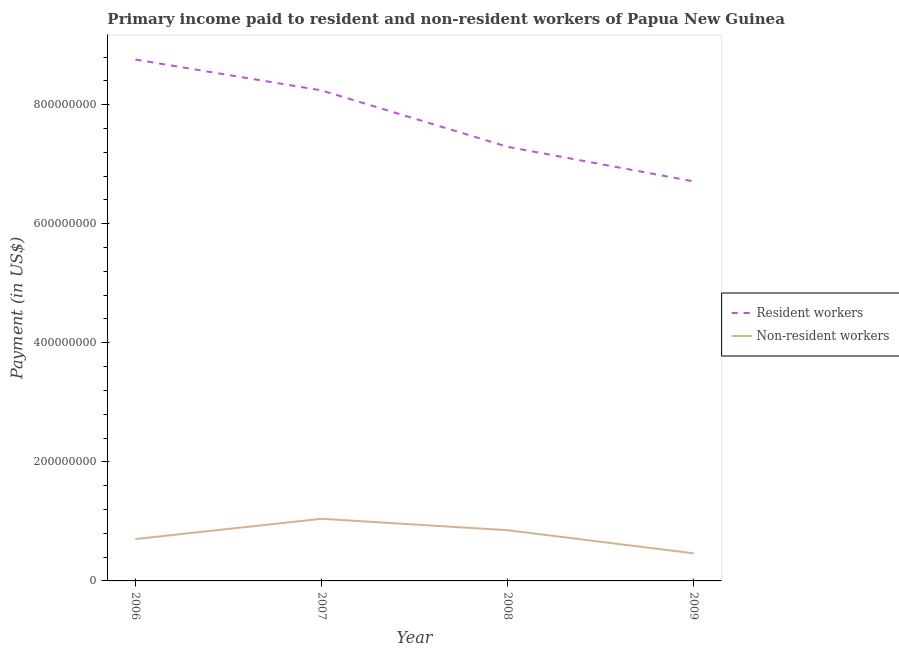Does the line corresponding to payment made to non-resident workers intersect with the line corresponding to payment made to resident workers?
Your response must be concise. No. Is the number of lines equal to the number of legend labels?
Provide a succinct answer. Yes. What is the payment made to non-resident workers in 2006?
Ensure brevity in your answer.  7.03e+07. Across all years, what is the maximum payment made to non-resident workers?
Ensure brevity in your answer.  1.04e+08. Across all years, what is the minimum payment made to non-resident workers?
Offer a terse response. 4.63e+07. In which year was the payment made to resident workers minimum?
Offer a terse response. 2009. What is the total payment made to non-resident workers in the graph?
Keep it short and to the point. 3.06e+08. What is the difference between the payment made to resident workers in 2006 and that in 2009?
Your answer should be compact. 2.05e+08. What is the difference between the payment made to non-resident workers in 2007 and the payment made to resident workers in 2008?
Keep it short and to the point. -6.25e+08. What is the average payment made to resident workers per year?
Ensure brevity in your answer.  7.75e+08. In the year 2009, what is the difference between the payment made to resident workers and payment made to non-resident workers?
Give a very brief answer. 6.25e+08. What is the ratio of the payment made to resident workers in 2008 to that in 2009?
Offer a very short reply. 1.09. Is the payment made to resident workers in 2006 less than that in 2007?
Give a very brief answer. No. What is the difference between the highest and the second highest payment made to non-resident workers?
Keep it short and to the point. 1.92e+07. What is the difference between the highest and the lowest payment made to non-resident workers?
Your answer should be very brief. 5.80e+07. In how many years, is the payment made to resident workers greater than the average payment made to resident workers taken over all years?
Offer a terse response. 2. Is the sum of the payment made to resident workers in 2007 and 2009 greater than the maximum payment made to non-resident workers across all years?
Your response must be concise. Yes. Is the payment made to non-resident workers strictly greater than the payment made to resident workers over the years?
Make the answer very short. No. Is the payment made to non-resident workers strictly less than the payment made to resident workers over the years?
Your response must be concise. Yes. How many lines are there?
Keep it short and to the point. 2. How many years are there in the graph?
Make the answer very short. 4. What is the difference between two consecutive major ticks on the Y-axis?
Offer a terse response. 2.00e+08. Does the graph contain any zero values?
Ensure brevity in your answer.  No. Does the graph contain grids?
Keep it short and to the point. No. Where does the legend appear in the graph?
Offer a very short reply. Center right. What is the title of the graph?
Offer a terse response. Primary income paid to resident and non-resident workers of Papua New Guinea. What is the label or title of the X-axis?
Your answer should be very brief. Year. What is the label or title of the Y-axis?
Ensure brevity in your answer.  Payment (in US$). What is the Payment (in US$) in Resident workers in 2006?
Ensure brevity in your answer.  8.76e+08. What is the Payment (in US$) in Non-resident workers in 2006?
Make the answer very short. 7.03e+07. What is the Payment (in US$) in Resident workers in 2007?
Your answer should be very brief. 8.24e+08. What is the Payment (in US$) of Non-resident workers in 2007?
Your response must be concise. 1.04e+08. What is the Payment (in US$) in Resident workers in 2008?
Offer a very short reply. 7.29e+08. What is the Payment (in US$) in Non-resident workers in 2008?
Your response must be concise. 8.51e+07. What is the Payment (in US$) in Resident workers in 2009?
Your answer should be compact. 6.71e+08. What is the Payment (in US$) in Non-resident workers in 2009?
Offer a very short reply. 4.63e+07. Across all years, what is the maximum Payment (in US$) in Resident workers?
Ensure brevity in your answer.  8.76e+08. Across all years, what is the maximum Payment (in US$) in Non-resident workers?
Provide a short and direct response. 1.04e+08. Across all years, what is the minimum Payment (in US$) of Resident workers?
Keep it short and to the point. 6.71e+08. Across all years, what is the minimum Payment (in US$) of Non-resident workers?
Your response must be concise. 4.63e+07. What is the total Payment (in US$) in Resident workers in the graph?
Offer a terse response. 3.10e+09. What is the total Payment (in US$) in Non-resident workers in the graph?
Your response must be concise. 3.06e+08. What is the difference between the Payment (in US$) of Resident workers in 2006 and that in 2007?
Your answer should be very brief. 5.18e+07. What is the difference between the Payment (in US$) in Non-resident workers in 2006 and that in 2007?
Your answer should be compact. -3.40e+07. What is the difference between the Payment (in US$) of Resident workers in 2006 and that in 2008?
Your answer should be very brief. 1.47e+08. What is the difference between the Payment (in US$) in Non-resident workers in 2006 and that in 2008?
Make the answer very short. -1.48e+07. What is the difference between the Payment (in US$) in Resident workers in 2006 and that in 2009?
Your answer should be very brief. 2.05e+08. What is the difference between the Payment (in US$) of Non-resident workers in 2006 and that in 2009?
Your answer should be compact. 2.40e+07. What is the difference between the Payment (in US$) in Resident workers in 2007 and that in 2008?
Offer a very short reply. 9.48e+07. What is the difference between the Payment (in US$) of Non-resident workers in 2007 and that in 2008?
Make the answer very short. 1.92e+07. What is the difference between the Payment (in US$) of Resident workers in 2007 and that in 2009?
Offer a very short reply. 1.53e+08. What is the difference between the Payment (in US$) in Non-resident workers in 2007 and that in 2009?
Your answer should be very brief. 5.80e+07. What is the difference between the Payment (in US$) of Resident workers in 2008 and that in 2009?
Offer a very short reply. 5.81e+07. What is the difference between the Payment (in US$) of Non-resident workers in 2008 and that in 2009?
Provide a succinct answer. 3.88e+07. What is the difference between the Payment (in US$) of Resident workers in 2006 and the Payment (in US$) of Non-resident workers in 2007?
Make the answer very short. 7.71e+08. What is the difference between the Payment (in US$) in Resident workers in 2006 and the Payment (in US$) in Non-resident workers in 2008?
Provide a succinct answer. 7.91e+08. What is the difference between the Payment (in US$) of Resident workers in 2006 and the Payment (in US$) of Non-resident workers in 2009?
Ensure brevity in your answer.  8.29e+08. What is the difference between the Payment (in US$) of Resident workers in 2007 and the Payment (in US$) of Non-resident workers in 2008?
Your answer should be compact. 7.39e+08. What is the difference between the Payment (in US$) in Resident workers in 2007 and the Payment (in US$) in Non-resident workers in 2009?
Keep it short and to the point. 7.78e+08. What is the difference between the Payment (in US$) in Resident workers in 2008 and the Payment (in US$) in Non-resident workers in 2009?
Ensure brevity in your answer.  6.83e+08. What is the average Payment (in US$) in Resident workers per year?
Ensure brevity in your answer.  7.75e+08. What is the average Payment (in US$) of Non-resident workers per year?
Your response must be concise. 7.66e+07. In the year 2006, what is the difference between the Payment (in US$) of Resident workers and Payment (in US$) of Non-resident workers?
Provide a short and direct response. 8.05e+08. In the year 2007, what is the difference between the Payment (in US$) of Resident workers and Payment (in US$) of Non-resident workers?
Give a very brief answer. 7.20e+08. In the year 2008, what is the difference between the Payment (in US$) of Resident workers and Payment (in US$) of Non-resident workers?
Ensure brevity in your answer.  6.44e+08. In the year 2009, what is the difference between the Payment (in US$) in Resident workers and Payment (in US$) in Non-resident workers?
Provide a succinct answer. 6.25e+08. What is the ratio of the Payment (in US$) of Resident workers in 2006 to that in 2007?
Offer a terse response. 1.06. What is the ratio of the Payment (in US$) of Non-resident workers in 2006 to that in 2007?
Offer a very short reply. 0.67. What is the ratio of the Payment (in US$) of Resident workers in 2006 to that in 2008?
Your answer should be compact. 1.2. What is the ratio of the Payment (in US$) in Non-resident workers in 2006 to that in 2008?
Offer a terse response. 0.83. What is the ratio of the Payment (in US$) of Resident workers in 2006 to that in 2009?
Offer a very short reply. 1.3. What is the ratio of the Payment (in US$) in Non-resident workers in 2006 to that in 2009?
Your answer should be compact. 1.52. What is the ratio of the Payment (in US$) of Resident workers in 2007 to that in 2008?
Offer a very short reply. 1.13. What is the ratio of the Payment (in US$) in Non-resident workers in 2007 to that in 2008?
Your answer should be compact. 1.23. What is the ratio of the Payment (in US$) of Resident workers in 2007 to that in 2009?
Provide a short and direct response. 1.23. What is the ratio of the Payment (in US$) of Non-resident workers in 2007 to that in 2009?
Your answer should be compact. 2.25. What is the ratio of the Payment (in US$) of Resident workers in 2008 to that in 2009?
Keep it short and to the point. 1.09. What is the ratio of the Payment (in US$) of Non-resident workers in 2008 to that in 2009?
Ensure brevity in your answer.  1.84. What is the difference between the highest and the second highest Payment (in US$) of Resident workers?
Keep it short and to the point. 5.18e+07. What is the difference between the highest and the second highest Payment (in US$) in Non-resident workers?
Offer a very short reply. 1.92e+07. What is the difference between the highest and the lowest Payment (in US$) of Resident workers?
Keep it short and to the point. 2.05e+08. What is the difference between the highest and the lowest Payment (in US$) of Non-resident workers?
Make the answer very short. 5.80e+07. 